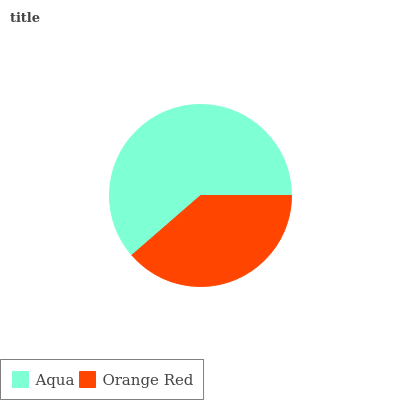Is Orange Red the minimum?
Answer yes or no. Yes. Is Aqua the maximum?
Answer yes or no. Yes. Is Orange Red the maximum?
Answer yes or no. No. Is Aqua greater than Orange Red?
Answer yes or no. Yes. Is Orange Red less than Aqua?
Answer yes or no. Yes. Is Orange Red greater than Aqua?
Answer yes or no. No. Is Aqua less than Orange Red?
Answer yes or no. No. Is Aqua the high median?
Answer yes or no. Yes. Is Orange Red the low median?
Answer yes or no. Yes. Is Orange Red the high median?
Answer yes or no. No. Is Aqua the low median?
Answer yes or no. No. 